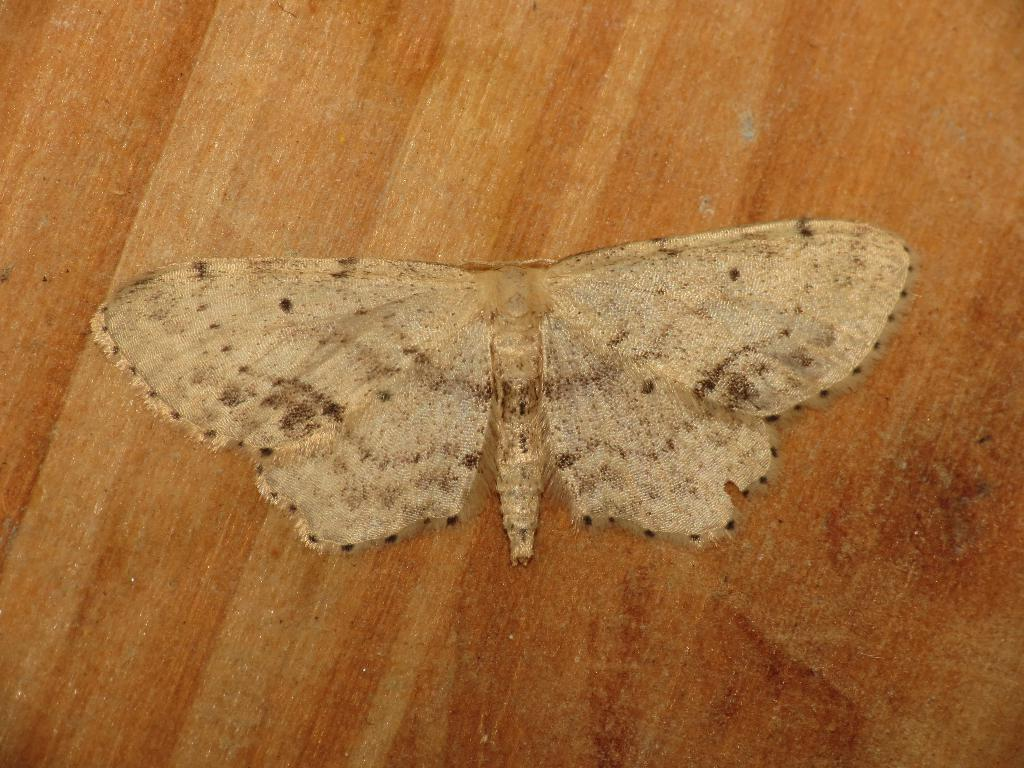What is the main subject of the image? The main subject of the image is a butterfly. Where is the butterfly located in the image? The butterfly is on a wooden surface. What type of wool is being used to grow the butterfly in the image? There is no wool or growth process depicted in the image; it simply features a butterfly on a wooden surface. 